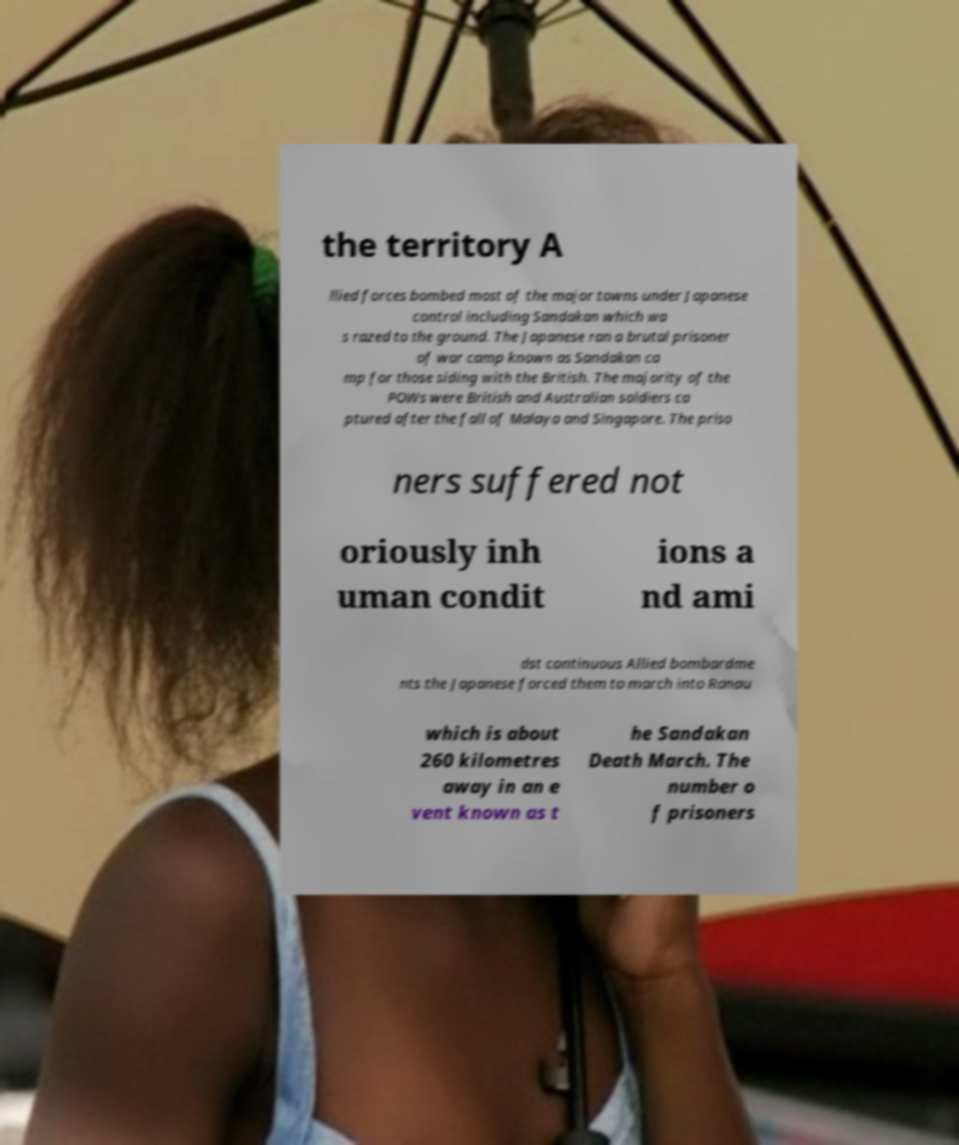What messages or text are displayed in this image? I need them in a readable, typed format. the territory A llied forces bombed most of the major towns under Japanese control including Sandakan which wa s razed to the ground. The Japanese ran a brutal prisoner of war camp known as Sandakan ca mp for those siding with the British. The majority of the POWs were British and Australian soldiers ca ptured after the fall of Malaya and Singapore. The priso ners suffered not oriously inh uman condit ions a nd ami dst continuous Allied bombardme nts the Japanese forced them to march into Ranau which is about 260 kilometres away in an e vent known as t he Sandakan Death March. The number o f prisoners 